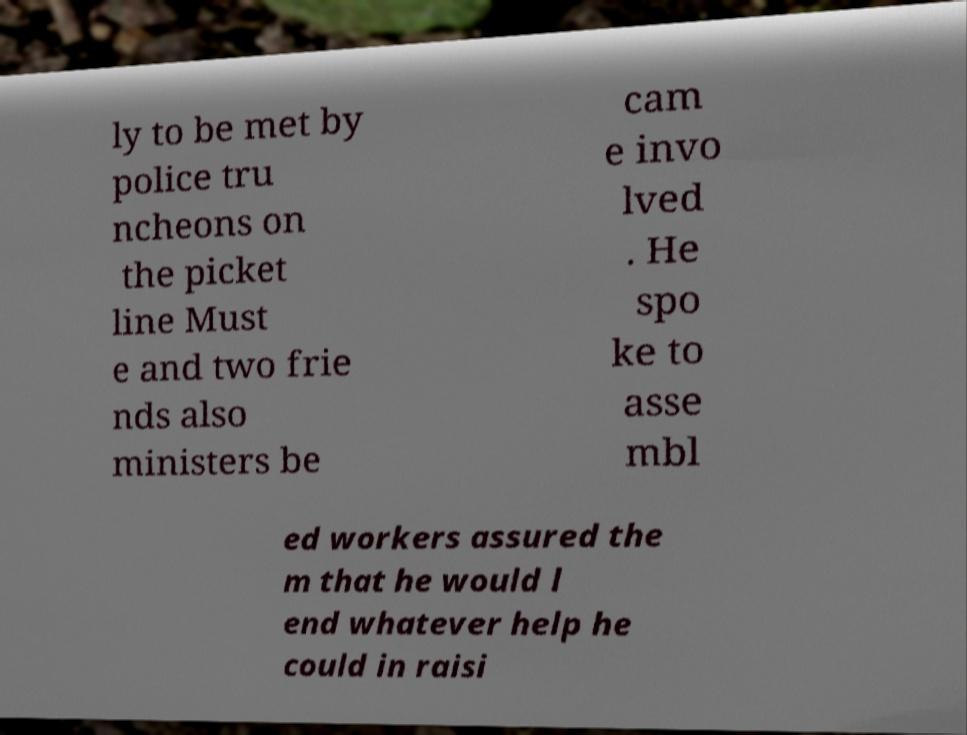There's text embedded in this image that I need extracted. Can you transcribe it verbatim? ly to be met by police tru ncheons on the picket line Must e and two frie nds also ministers be cam e invo lved . He spo ke to asse mbl ed workers assured the m that he would l end whatever help he could in raisi 